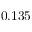<formula> <loc_0><loc_0><loc_500><loc_500>0 . 1 3 5</formula> 